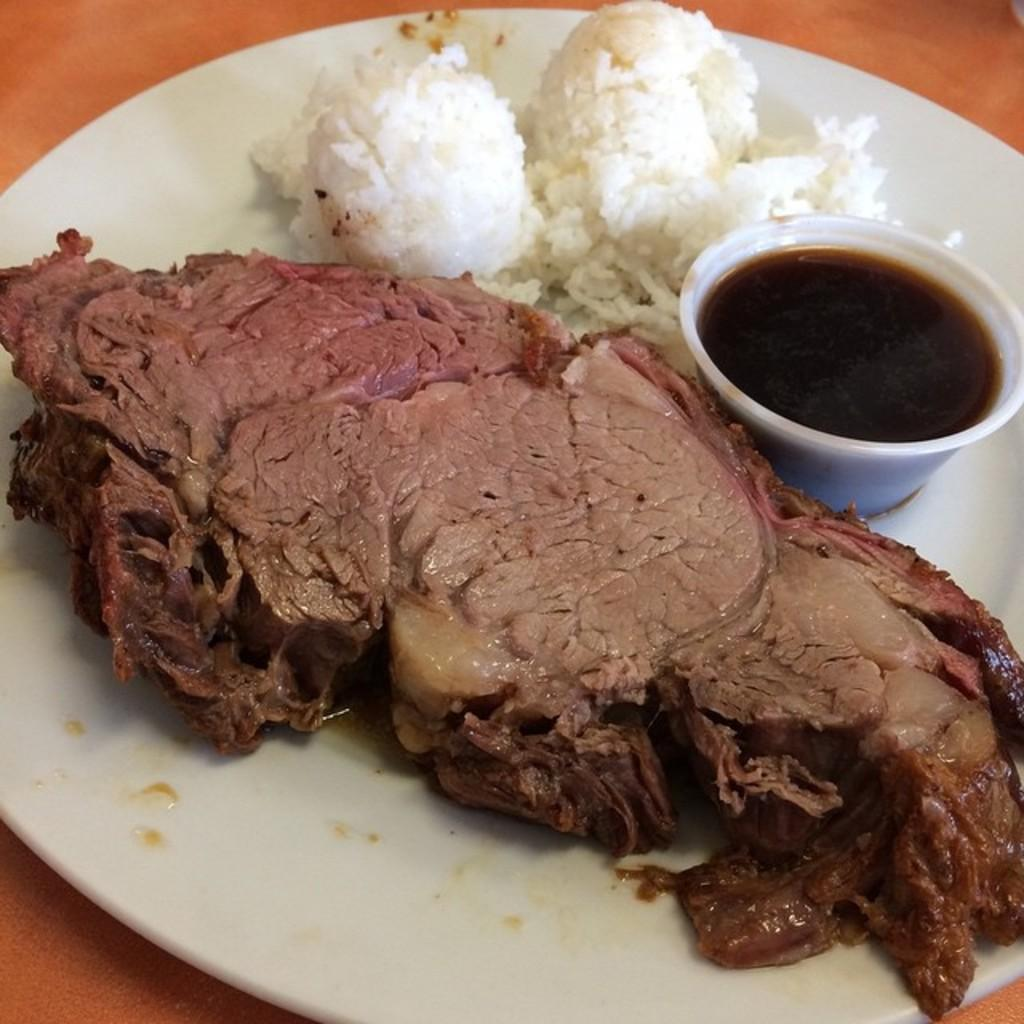What type of food can be seen in the image? The food in the image has white and brown colors. What is used to hold the food in the image? There is a bowl in the image that holds something. What color is the surface that the plate is on? The plate is on an orange surface. What type of prose is being recited by the food in the image? There is no indication in the image that the food is reciting any prose. 